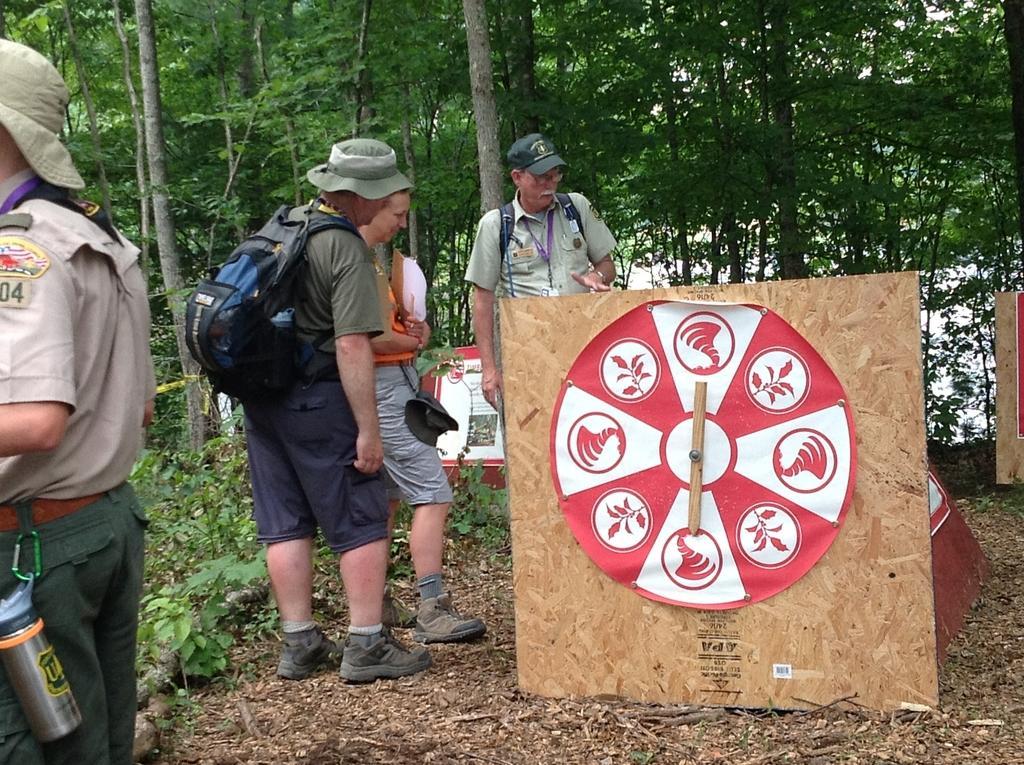In one or two sentences, can you explain what this image depicts? In this image I can see the group of people with different color dresses and also I can see few people wearing the bags. I can see few people with the caps and hat. To the side I can see many boards. In the background there are many trees. 